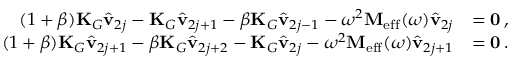Convert formula to latex. <formula><loc_0><loc_0><loc_500><loc_500>\begin{array} { r l } { ( 1 + \beta ) K _ { G } \hat { v } _ { 2 j } - K _ { G } \hat { v } _ { 2 j + 1 } - \beta K _ { G } \hat { v } _ { 2 j - 1 } - \omega ^ { 2 } M _ { e f f } ( \omega ) \hat { v } _ { 2 j } } & { = 0 \, , } \\ { ( 1 + \beta ) K _ { G } \hat { v } _ { 2 j + 1 } - \beta K _ { G } \hat { v } _ { 2 j + 2 } - K _ { G } \hat { v } _ { 2 j } - \omega ^ { 2 } M _ { e f f } ( \omega ) \hat { v } _ { 2 j + 1 } } & { = 0 \, . } \end{array}</formula> 